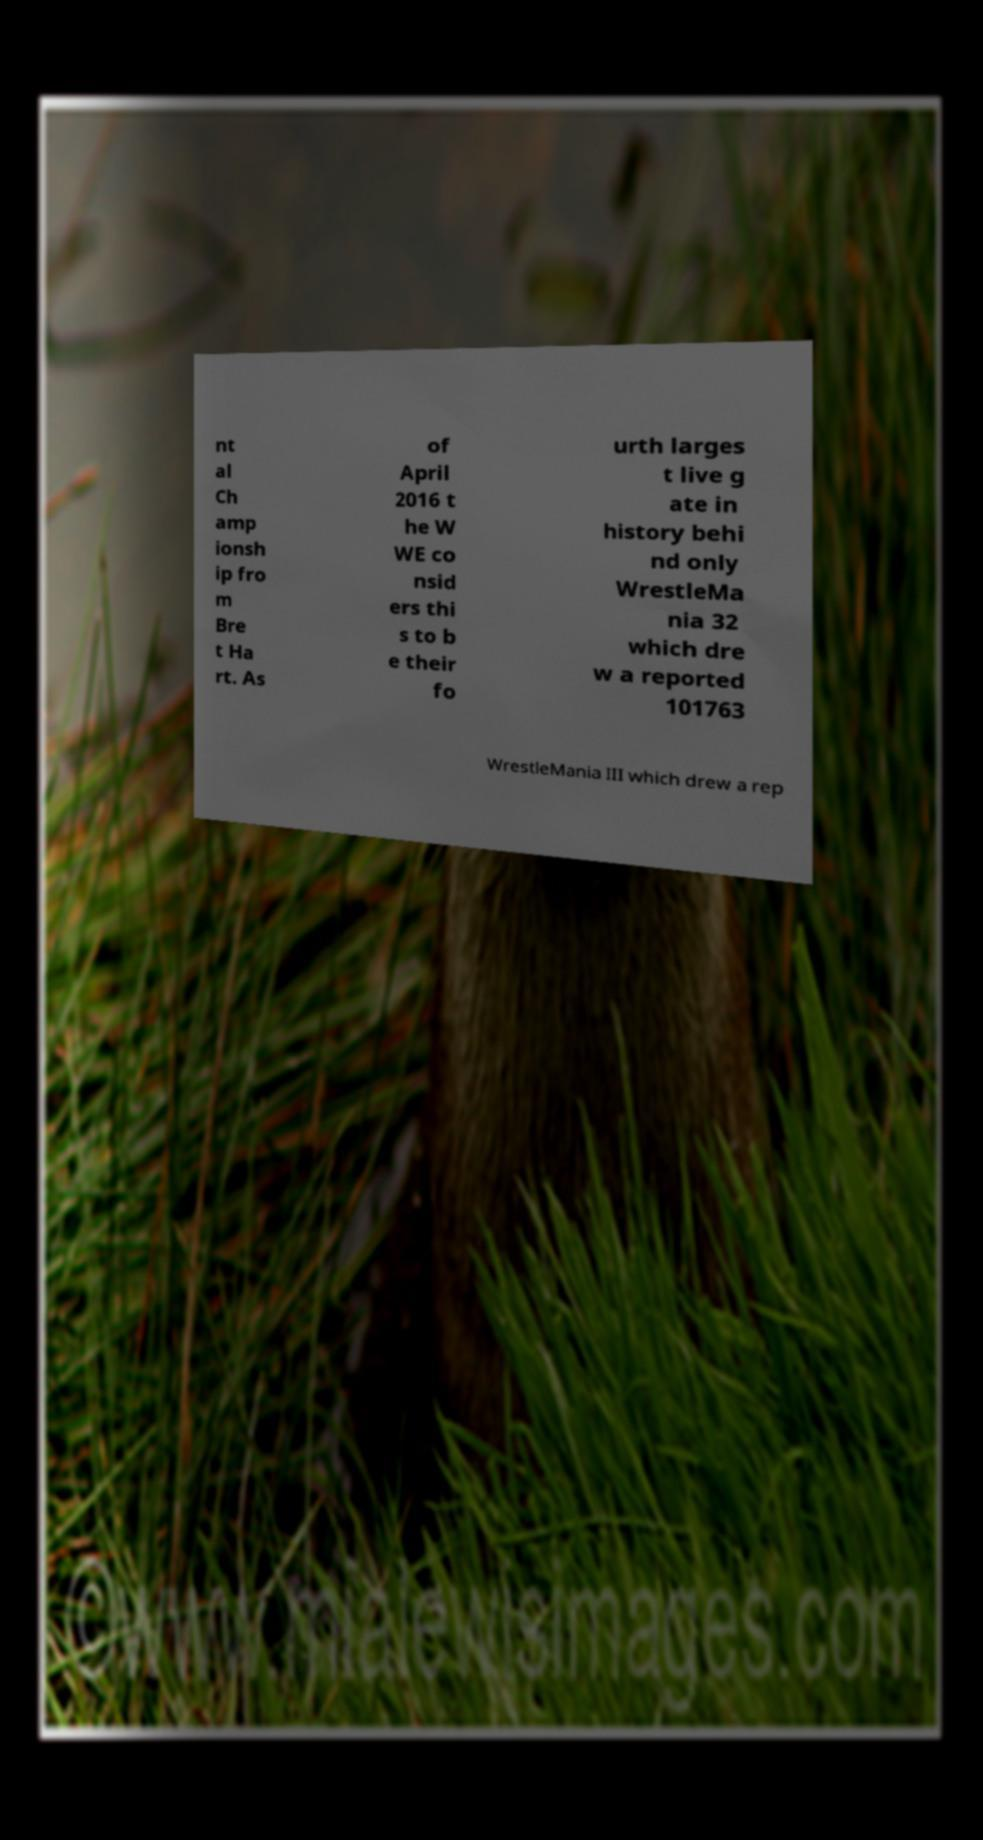Could you extract and type out the text from this image? nt al Ch amp ionsh ip fro m Bre t Ha rt. As of April 2016 t he W WE co nsid ers thi s to b e their fo urth larges t live g ate in history behi nd only WrestleMa nia 32 which dre w a reported 101763 WrestleMania III which drew a rep 